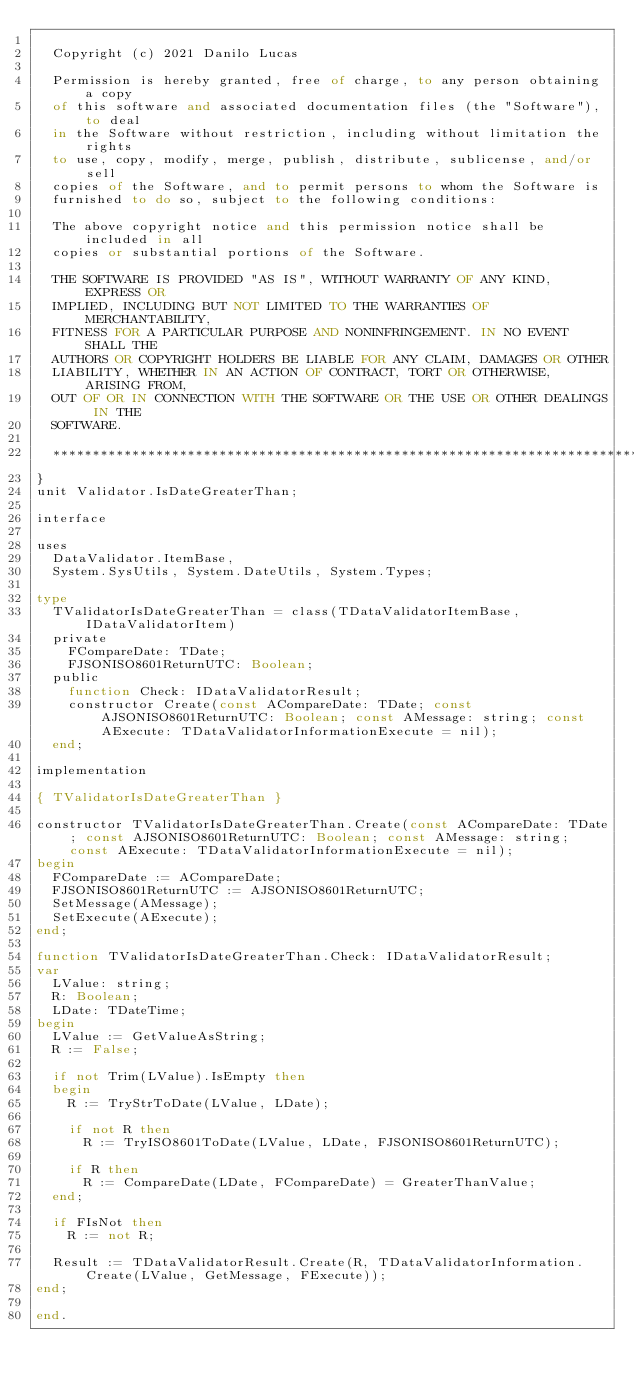Convert code to text. <code><loc_0><loc_0><loc_500><loc_500><_Pascal_>
  Copyright (c) 2021 Danilo Lucas

  Permission is hereby granted, free of charge, to any person obtaining a copy
  of this software and associated documentation files (the "Software"), to deal
  in the Software without restriction, including without limitation the rights
  to use, copy, modify, merge, publish, distribute, sublicense, and/or sell
  copies of the Software, and to permit persons to whom the Software is
  furnished to do so, subject to the following conditions:

  The above copyright notice and this permission notice shall be included in all
  copies or substantial portions of the Software.

  THE SOFTWARE IS PROVIDED "AS IS", WITHOUT WARRANTY OF ANY KIND, EXPRESS OR
  IMPLIED, INCLUDING BUT NOT LIMITED TO THE WARRANTIES OF MERCHANTABILITY,
  FITNESS FOR A PARTICULAR PURPOSE AND NONINFRINGEMENT. IN NO EVENT SHALL THE
  AUTHORS OR COPYRIGHT HOLDERS BE LIABLE FOR ANY CLAIM, DAMAGES OR OTHER
  LIABILITY, WHETHER IN AN ACTION OF CONTRACT, TORT OR OTHERWISE, ARISING FROM,
  OUT OF OR IN CONNECTION WITH THE SOFTWARE OR THE USE OR OTHER DEALINGS IN THE
  SOFTWARE.

  ********************************************************************************
}
unit Validator.IsDateGreaterThan;

interface

uses
  DataValidator.ItemBase,
  System.SysUtils, System.DateUtils, System.Types;

type
  TValidatorIsDateGreaterThan = class(TDataValidatorItemBase, IDataValidatorItem)
  private
    FCompareDate: TDate;
    FJSONISO8601ReturnUTC: Boolean;
  public
    function Check: IDataValidatorResult;
    constructor Create(const ACompareDate: TDate; const AJSONISO8601ReturnUTC: Boolean; const AMessage: string; const AExecute: TDataValidatorInformationExecute = nil);
  end;

implementation

{ TValidatorIsDateGreaterThan }

constructor TValidatorIsDateGreaterThan.Create(const ACompareDate: TDate; const AJSONISO8601ReturnUTC: Boolean; const AMessage: string; const AExecute: TDataValidatorInformationExecute = nil);
begin
  FCompareDate := ACompareDate;
  FJSONISO8601ReturnUTC := AJSONISO8601ReturnUTC;
  SetMessage(AMessage);
  SetExecute(AExecute);
end;

function TValidatorIsDateGreaterThan.Check: IDataValidatorResult;
var
  LValue: string;
  R: Boolean;
  LDate: TDateTime;
begin
  LValue := GetValueAsString;
  R := False;

  if not Trim(LValue).IsEmpty then
  begin
    R := TryStrToDate(LValue, LDate);

    if not R then
      R := TryISO8601ToDate(LValue, LDate, FJSONISO8601ReturnUTC);

    if R then
      R := CompareDate(LDate, FCompareDate) = GreaterThanValue;
  end;

  if FIsNot then
    R := not R;

  Result := TDataValidatorResult.Create(R, TDataValidatorInformation.Create(LValue, GetMessage, FExecute));
end;

end.
</code> 